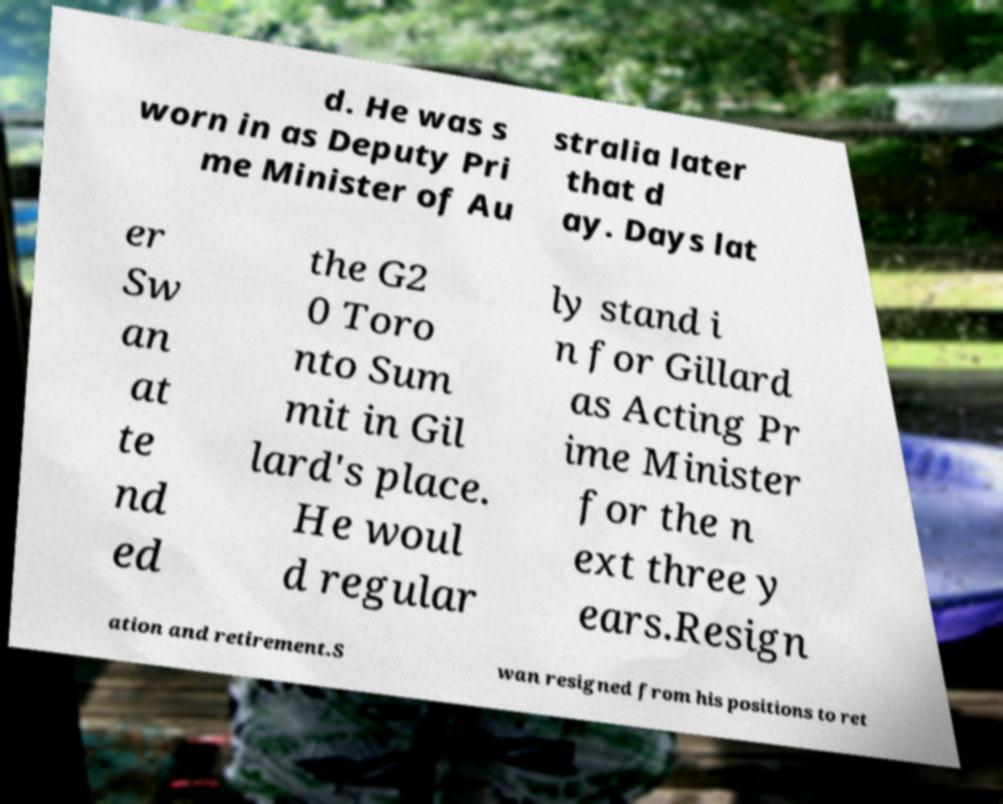There's text embedded in this image that I need extracted. Can you transcribe it verbatim? d. He was s worn in as Deputy Pri me Minister of Au stralia later that d ay. Days lat er Sw an at te nd ed the G2 0 Toro nto Sum mit in Gil lard's place. He woul d regular ly stand i n for Gillard as Acting Pr ime Minister for the n ext three y ears.Resign ation and retirement.S wan resigned from his positions to ret 